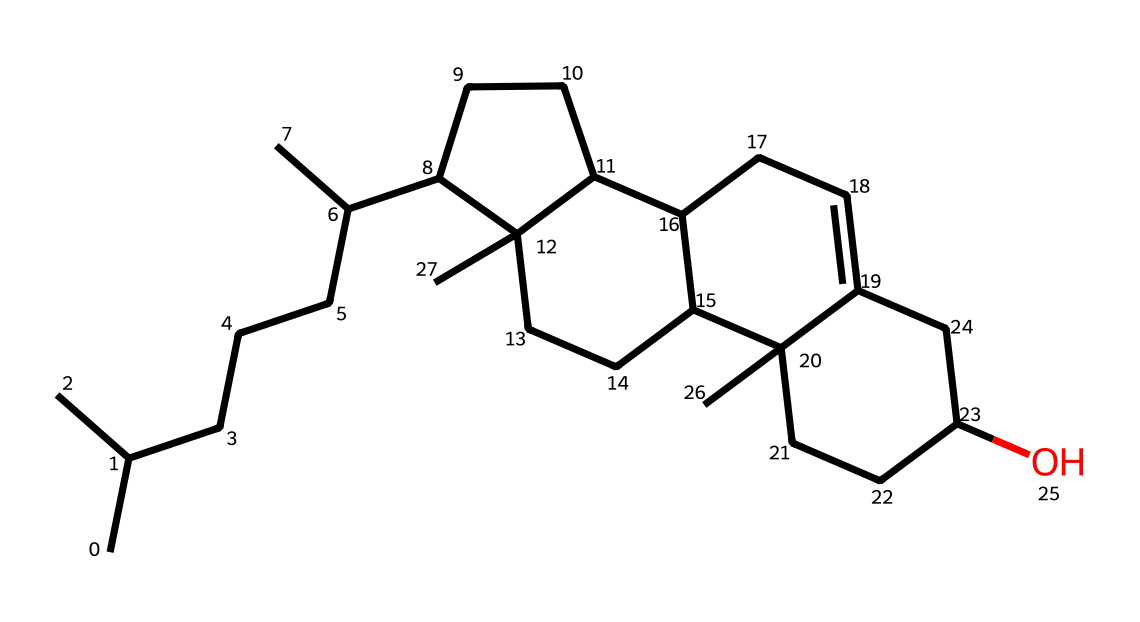What is the molecular formula of this cholesterol structure? The SMILES representation can be translated to determine the molecular formula by counting the carbon (C), hydrogen (H), and oxygen (O) atoms. In this case, the structure contains 27 carbons, 46 hydrogens, and 1 oxygen.
Answer: C27H46O How many rings are present in the cholesterol structure? By examining the SMILES, we can identify multiple cyclic structures. In this case, there are 4 rings present in the cholesterol structure.
Answer: 4 What type of lipid is cholesterol classified as? Cholesterol is considered a sterol, which is a subclass of steroids. Since the structure exhibits a sterol backbone with hydrocarbon rings, its classification aligns with this category.
Answer: sterol What role does cholesterol play in cellular membranes? Cholesterol is essential for maintaining membrane fluidity in cells, preventing excessive permeability and providing structural integrity to the membrane.
Answer: membrane fluidity Which functional group is present in this cholesterol structure? An alcohol functional group is identified by the presence of the hydroxyl group (-OH) at one end of the structure. This indicates its classification as a sterol.
Answer: hydroxyl group Is this structure associated with performance-enhancing substances? Yes, cholesterol is often found in various performance-enhancing substances, including anabolic steroids, which are derivatives of cholesterol.
Answer: yes 